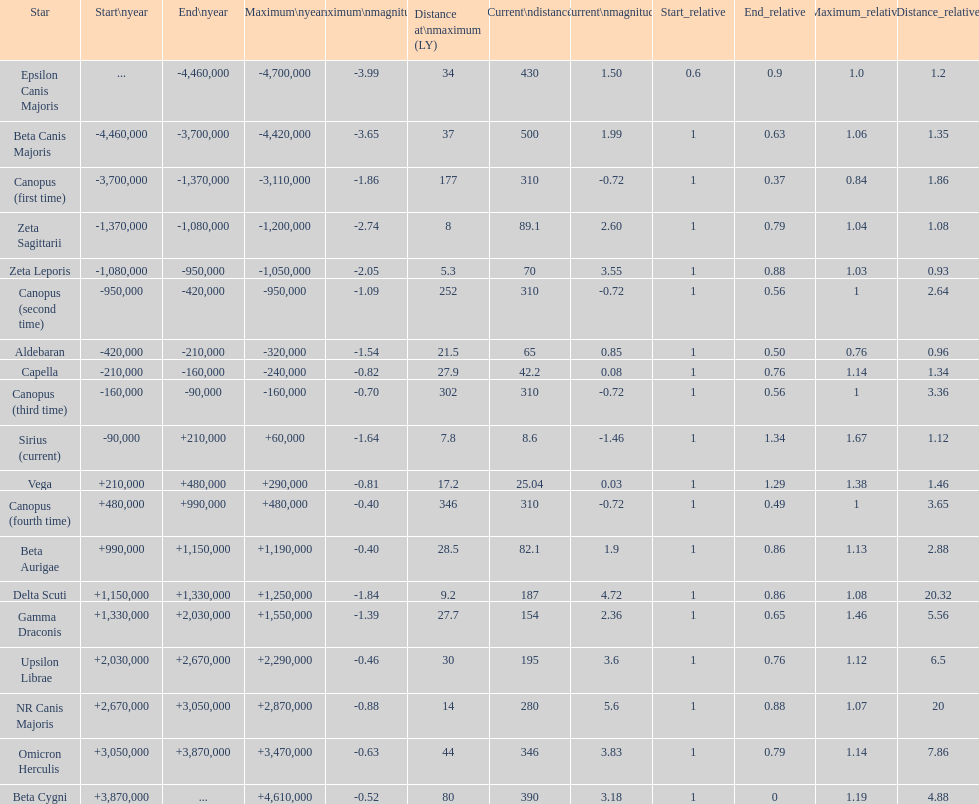Is capella's current magnitude more than vega's current magnitude? Yes. 